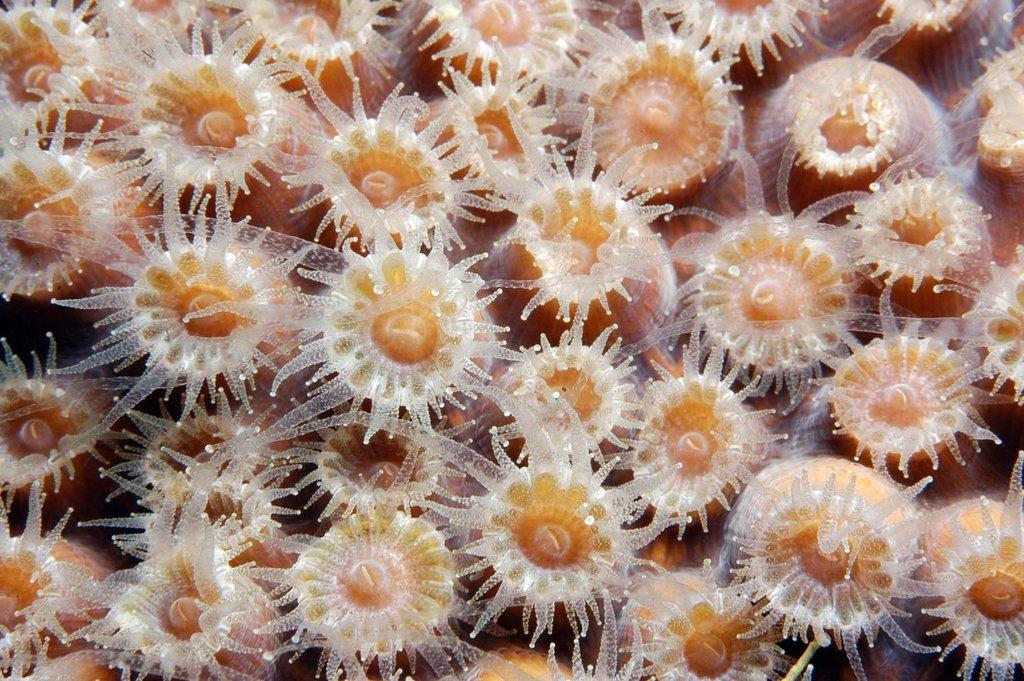What type of organisms can be seen in the image? There are white and orange polyps in the image. What are the polyps part of? The polyps are part of coral reefs. What type of pest is causing destruction to the coral reefs in the image? There is no pest or destruction visible in the image; it only shows white and orange polyps that are part of coral reefs. 